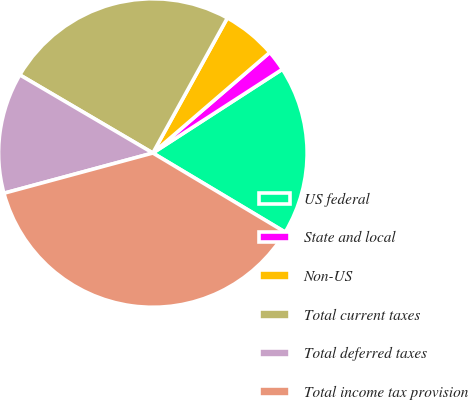Convert chart. <chart><loc_0><loc_0><loc_500><loc_500><pie_chart><fcel>US federal<fcel>State and local<fcel>Non-US<fcel>Total current taxes<fcel>Total deferred taxes<fcel>Total income tax provision<nl><fcel>17.71%<fcel>2.17%<fcel>5.67%<fcel>24.57%<fcel>12.65%<fcel>37.22%<nl></chart> 